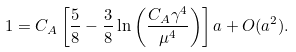<formula> <loc_0><loc_0><loc_500><loc_500>1 = C _ { A } \left [ \frac { 5 } { 8 } - \frac { 3 } { 8 } \ln \left ( \frac { C _ { A } \gamma ^ { 4 } } { \mu ^ { 4 } } \right ) \right ] a + O ( a ^ { 2 } ) .</formula> 